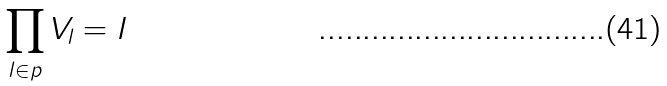Convert formula to latex. <formula><loc_0><loc_0><loc_500><loc_500>\prod _ { l \in p } V _ { l } = I</formula> 